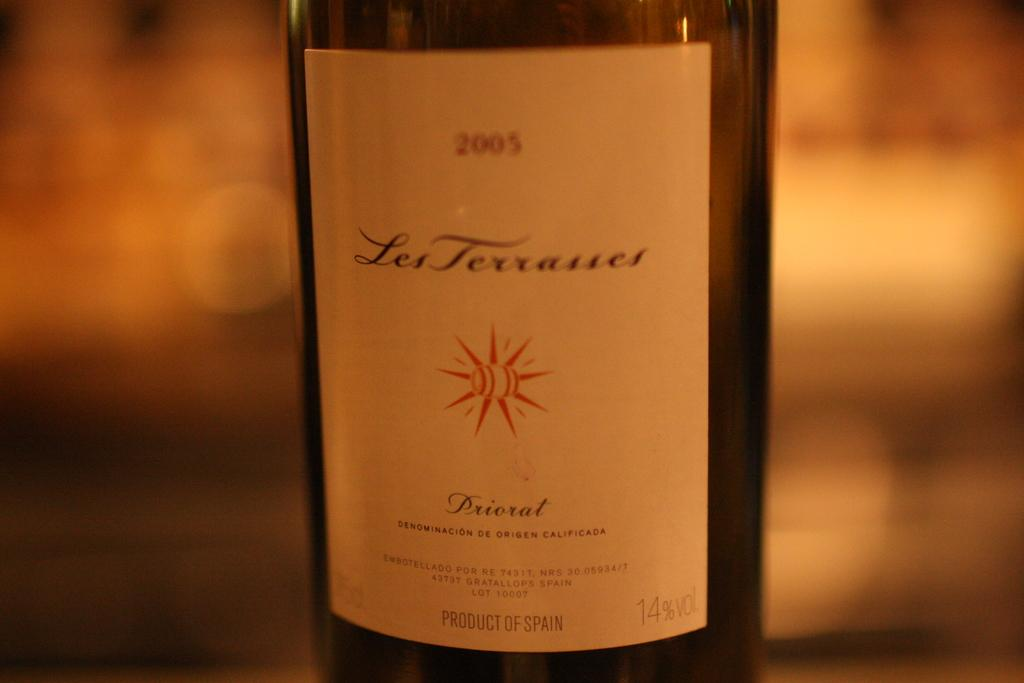<image>
Render a clear and concise summary of the photo. A 2005 Les Tevasses Priorat wine which is a product of Spain. 